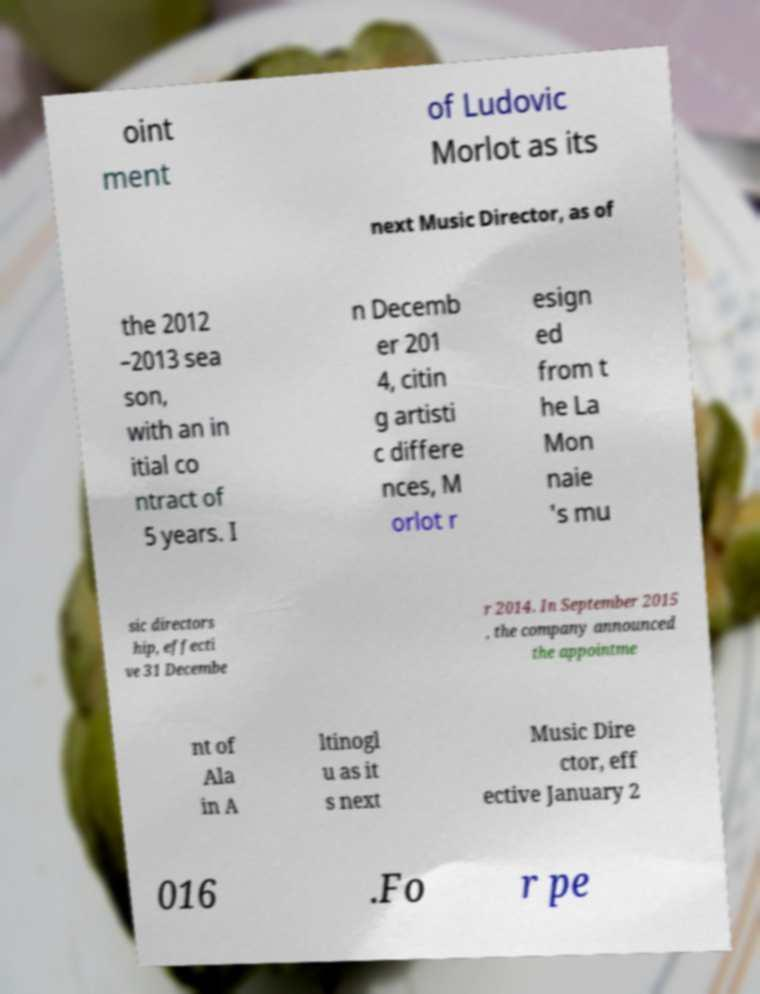Could you assist in decoding the text presented in this image and type it out clearly? oint ment of Ludovic Morlot as its next Music Director, as of the 2012 –2013 sea son, with an in itial co ntract of 5 years. I n Decemb er 201 4, citin g artisti c differe nces, M orlot r esign ed from t he La Mon naie 's mu sic directors hip, effecti ve 31 Decembe r 2014. In September 2015 , the company announced the appointme nt of Ala in A ltinogl u as it s next Music Dire ctor, eff ective January 2 016 .Fo r pe 